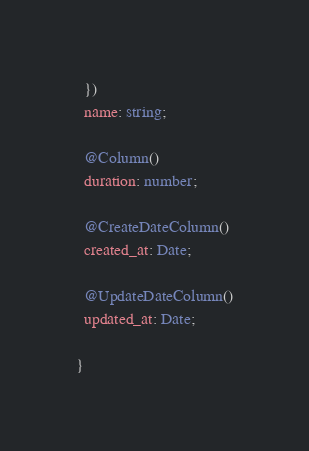Convert code to text. <code><loc_0><loc_0><loc_500><loc_500><_TypeScript_>  })
  name: string;

  @Column()
  duration: number;

  @CreateDateColumn()
  created_at: Date;

  @UpdateDateColumn()
  updated_at: Date;
  
}
</code> 